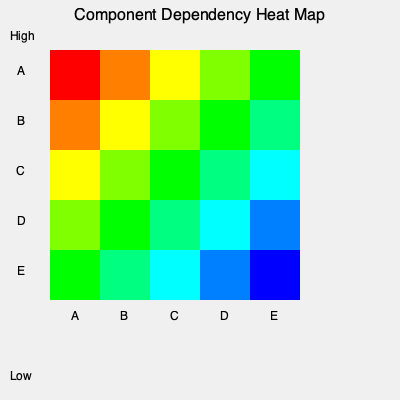Based on the heat map of software component dependencies, which component poses the highest risk to system stability if modified, and what strategy would you recommend to minimize this risk while maintaining system reliability? To answer this question, we need to analyze the heat map and consider the implications for system stability:

1. Interpret the heat map:
   - Red indicates high dependency, blue indicates low dependency.
   - The diagonal represents self-dependency (always high).

2. Identify the component with the highest risk:
   - Component A (first row/column) has the most red and orange cells.
   - This indicates that Component A has the highest number of strong dependencies with other components.

3. Implications for system stability:
   - Modifying Component A is likely to affect multiple other components.
   - Changes to A could potentially cause cascading effects throughout the system.

4. Risk minimization strategy:
   a) Isolate Component A:
      - Gradually reduce dependencies on A by refactoring other components.
      - Implement well-defined interfaces to limit the impact of changes.
   
   b) Implement robust testing:
      - Develop comprehensive unit and integration tests for Component A.
      - Ensure thorough regression testing when A is modified.
   
   c) Version control and change management:
      - Strictly control changes to Component A.
      - Implement a more rigorous review process for modifications to A.
   
   d) Modularization:
      - Consider breaking down Component A into smaller, more manageable sub-components.
      - This can help isolate functionality and reduce the overall impact of changes.

5. Maintaining system reliability:
   - Prioritize stability by implementing changes incrementally.
   - Monitor system performance closely after any modifications to Component A.
   - Maintain detailed documentation of A's interfaces and dependencies.

By following this strategy, you can minimize the risk associated with modifying Component A while maintaining overall system stability and reliability.
Answer: Component A poses the highest risk. Isolate it through refactoring, implement robust testing, strictly control changes, and consider modularization to maintain stability. 